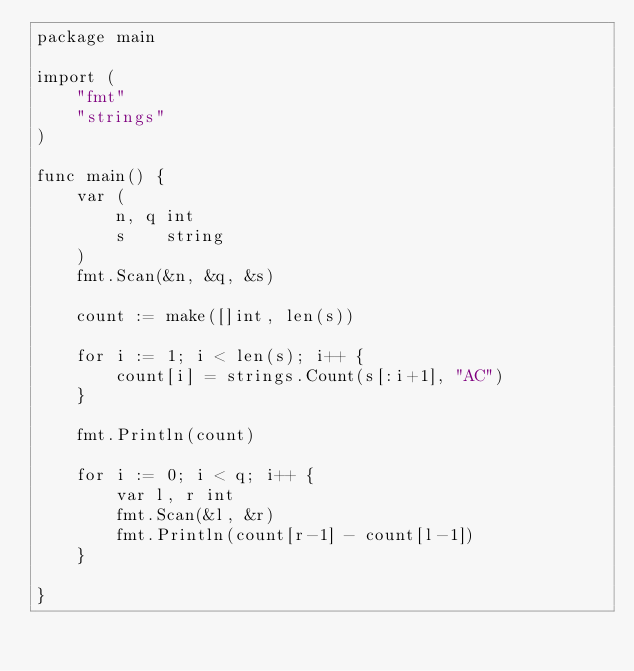<code> <loc_0><loc_0><loc_500><loc_500><_Go_>package main

import (
	"fmt"
	"strings"
)

func main() {
	var (
		n, q int
		s    string
	)
	fmt.Scan(&n, &q, &s)

	count := make([]int, len(s))

	for i := 1; i < len(s); i++ {
		count[i] = strings.Count(s[:i+1], "AC")
	}

	fmt.Println(count)

	for i := 0; i < q; i++ {
		var l, r int
		fmt.Scan(&l, &r)
		fmt.Println(count[r-1] - count[l-1])
	}

}
</code> 